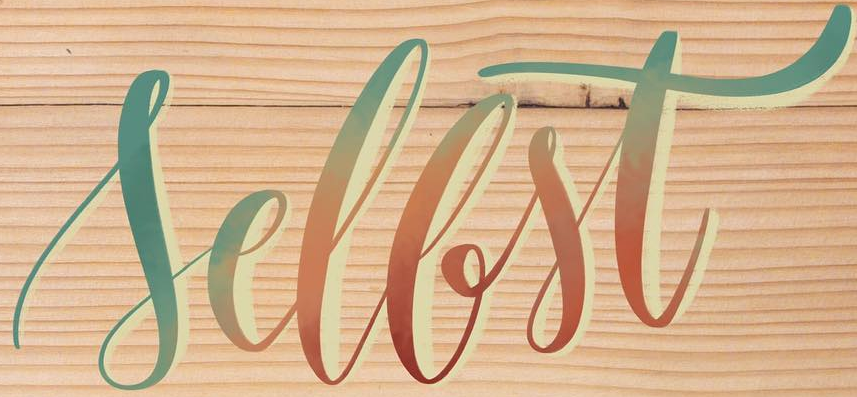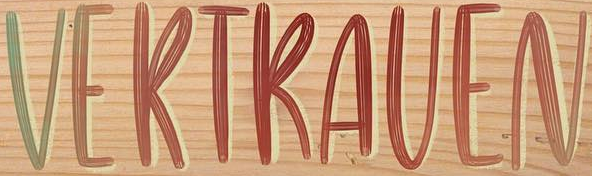What text is displayed in these images sequentially, separated by a semicolon? Sellst; VERTRAVEN 